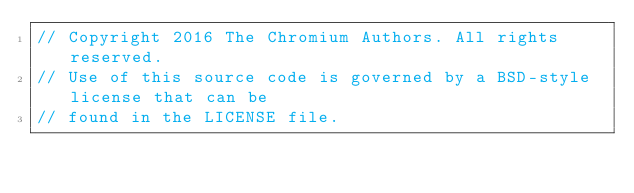Convert code to text. <code><loc_0><loc_0><loc_500><loc_500><_C_>// Copyright 2016 The Chromium Authors. All rights reserved.
// Use of this source code is governed by a BSD-style license that can be
// found in the LICENSE file.
</code> 